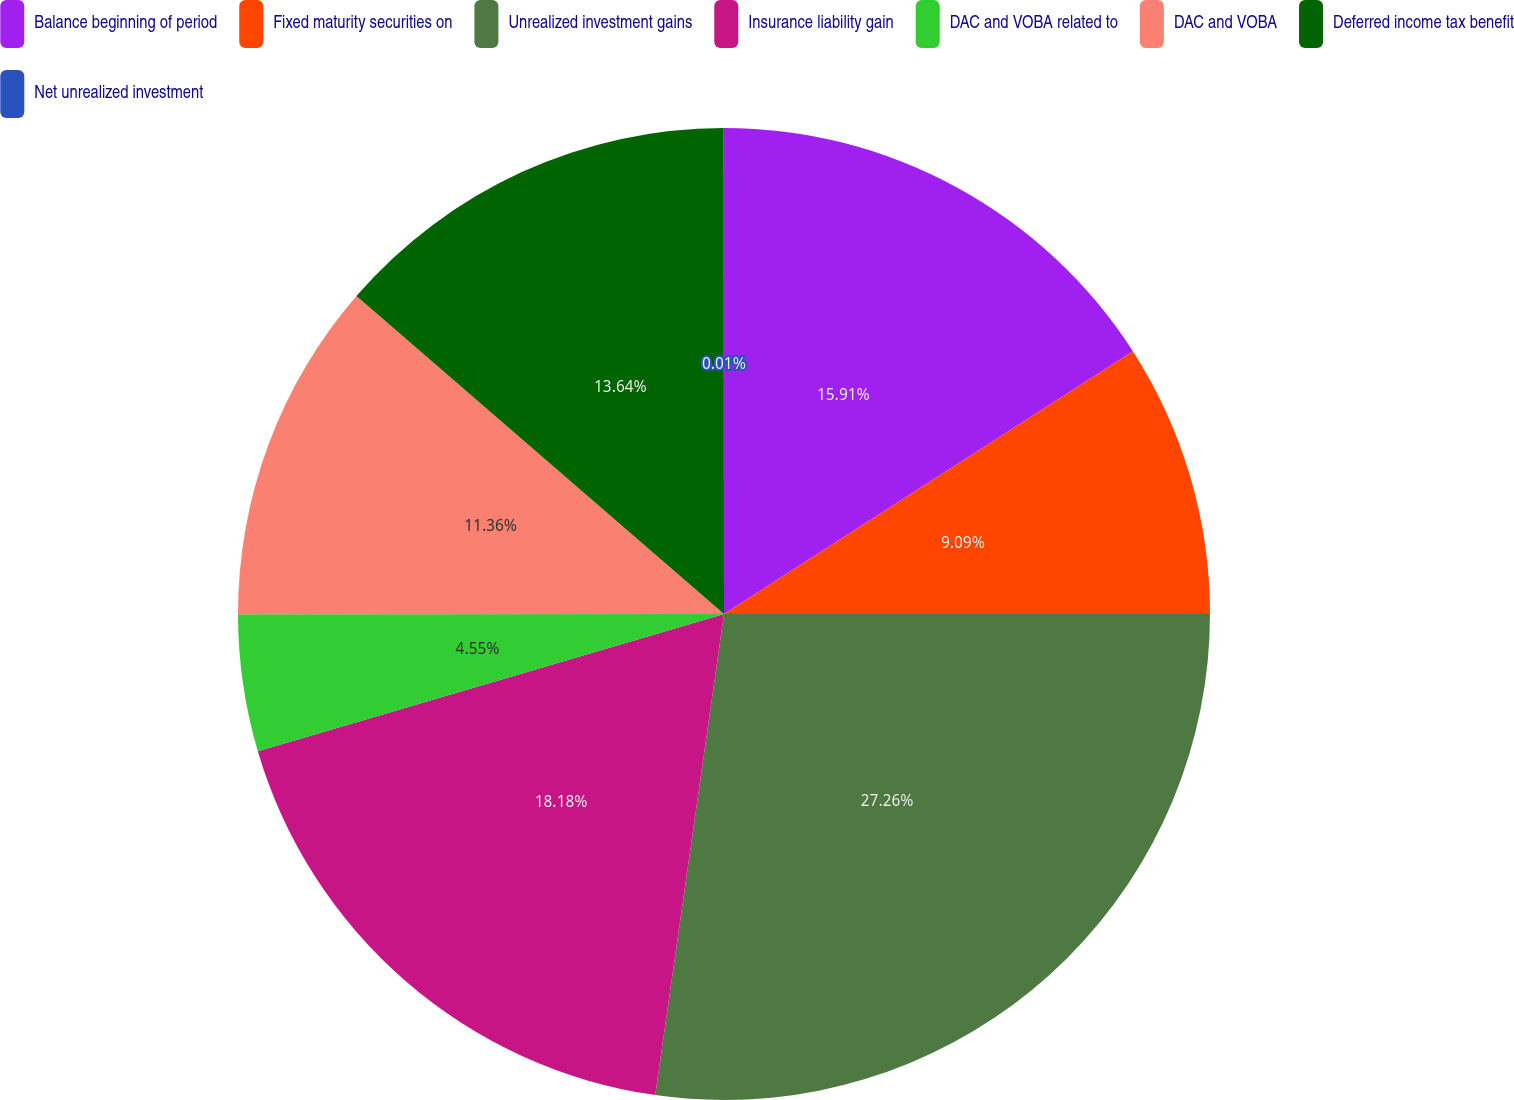Convert chart. <chart><loc_0><loc_0><loc_500><loc_500><pie_chart><fcel>Balance beginning of period<fcel>Fixed maturity securities on<fcel>Unrealized investment gains<fcel>Insurance liability gain<fcel>DAC and VOBA related to<fcel>DAC and VOBA<fcel>Deferred income tax benefit<fcel>Net unrealized investment<nl><fcel>15.91%<fcel>9.09%<fcel>27.26%<fcel>18.18%<fcel>4.55%<fcel>11.36%<fcel>13.64%<fcel>0.01%<nl></chart> 